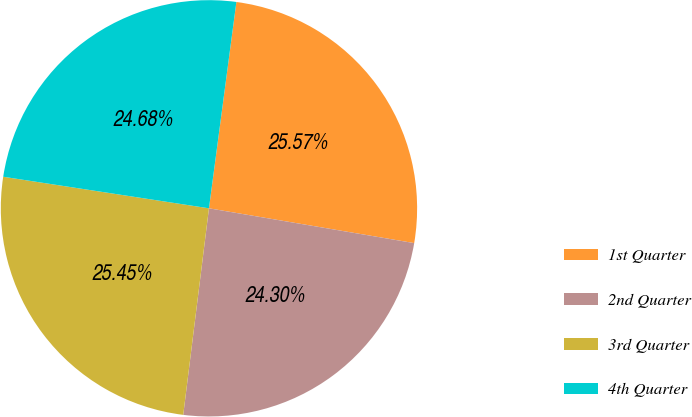Convert chart. <chart><loc_0><loc_0><loc_500><loc_500><pie_chart><fcel>1st Quarter<fcel>2nd Quarter<fcel>3rd Quarter<fcel>4th Quarter<nl><fcel>25.57%<fcel>24.3%<fcel>25.45%<fcel>24.68%<nl></chart> 